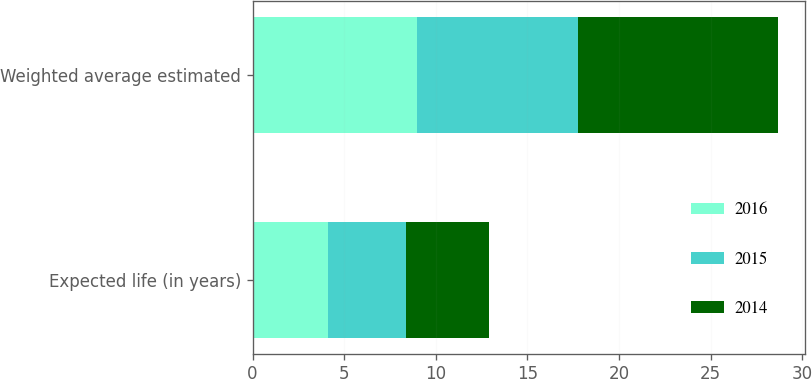Convert chart to OTSL. <chart><loc_0><loc_0><loc_500><loc_500><stacked_bar_chart><ecel><fcel>Expected life (in years)<fcel>Weighted average estimated<nl><fcel>2016<fcel>4.1<fcel>8.97<nl><fcel>2015<fcel>4.3<fcel>8.77<nl><fcel>2014<fcel>4.5<fcel>10.95<nl></chart> 